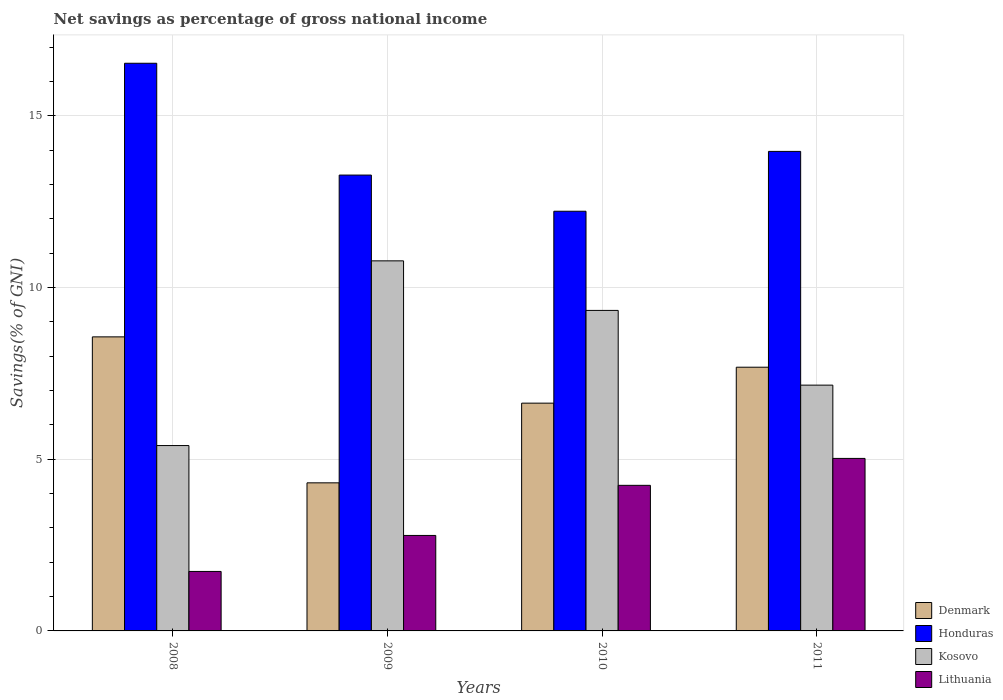How many groups of bars are there?
Keep it short and to the point. 4. Are the number of bars per tick equal to the number of legend labels?
Ensure brevity in your answer.  Yes. Are the number of bars on each tick of the X-axis equal?
Your answer should be compact. Yes. How many bars are there on the 3rd tick from the left?
Provide a succinct answer. 4. What is the label of the 1st group of bars from the left?
Offer a terse response. 2008. In how many cases, is the number of bars for a given year not equal to the number of legend labels?
Your answer should be compact. 0. What is the total savings in Lithuania in 2009?
Your answer should be very brief. 2.78. Across all years, what is the maximum total savings in Honduras?
Your answer should be very brief. 16.53. Across all years, what is the minimum total savings in Honduras?
Ensure brevity in your answer.  12.22. What is the total total savings in Lithuania in the graph?
Offer a terse response. 13.77. What is the difference between the total savings in Honduras in 2008 and that in 2009?
Provide a short and direct response. 3.26. What is the difference between the total savings in Kosovo in 2008 and the total savings in Denmark in 2010?
Your answer should be very brief. -1.23. What is the average total savings in Denmark per year?
Offer a terse response. 6.8. In the year 2009, what is the difference between the total savings in Honduras and total savings in Kosovo?
Provide a succinct answer. 2.5. What is the ratio of the total savings in Denmark in 2008 to that in 2009?
Provide a succinct answer. 1.99. Is the difference between the total savings in Honduras in 2008 and 2009 greater than the difference between the total savings in Kosovo in 2008 and 2009?
Your response must be concise. Yes. What is the difference between the highest and the second highest total savings in Kosovo?
Your answer should be very brief. 1.44. What is the difference between the highest and the lowest total savings in Kosovo?
Make the answer very short. 5.38. In how many years, is the total savings in Lithuania greater than the average total savings in Lithuania taken over all years?
Provide a succinct answer. 2. What does the 3rd bar from the left in 2008 represents?
Ensure brevity in your answer.  Kosovo. What does the 4th bar from the right in 2011 represents?
Your response must be concise. Denmark. Is it the case that in every year, the sum of the total savings in Honduras and total savings in Lithuania is greater than the total savings in Kosovo?
Offer a terse response. Yes. What is the difference between two consecutive major ticks on the Y-axis?
Offer a very short reply. 5. Are the values on the major ticks of Y-axis written in scientific E-notation?
Provide a succinct answer. No. Where does the legend appear in the graph?
Give a very brief answer. Bottom right. What is the title of the graph?
Keep it short and to the point. Net savings as percentage of gross national income. What is the label or title of the Y-axis?
Keep it short and to the point. Savings(% of GNI). What is the Savings(% of GNI) in Denmark in 2008?
Provide a succinct answer. 8.56. What is the Savings(% of GNI) in Honduras in 2008?
Provide a short and direct response. 16.53. What is the Savings(% of GNI) in Kosovo in 2008?
Offer a very short reply. 5.4. What is the Savings(% of GNI) in Lithuania in 2008?
Provide a short and direct response. 1.73. What is the Savings(% of GNI) of Denmark in 2009?
Give a very brief answer. 4.31. What is the Savings(% of GNI) in Honduras in 2009?
Ensure brevity in your answer.  13.27. What is the Savings(% of GNI) of Kosovo in 2009?
Offer a terse response. 10.77. What is the Savings(% of GNI) in Lithuania in 2009?
Ensure brevity in your answer.  2.78. What is the Savings(% of GNI) in Denmark in 2010?
Offer a very short reply. 6.63. What is the Savings(% of GNI) of Honduras in 2010?
Your response must be concise. 12.22. What is the Savings(% of GNI) in Kosovo in 2010?
Provide a succinct answer. 9.33. What is the Savings(% of GNI) in Lithuania in 2010?
Offer a terse response. 4.24. What is the Savings(% of GNI) of Denmark in 2011?
Give a very brief answer. 7.68. What is the Savings(% of GNI) in Honduras in 2011?
Offer a very short reply. 13.96. What is the Savings(% of GNI) in Kosovo in 2011?
Your response must be concise. 7.16. What is the Savings(% of GNI) of Lithuania in 2011?
Provide a short and direct response. 5.02. Across all years, what is the maximum Savings(% of GNI) of Denmark?
Provide a succinct answer. 8.56. Across all years, what is the maximum Savings(% of GNI) of Honduras?
Your answer should be very brief. 16.53. Across all years, what is the maximum Savings(% of GNI) in Kosovo?
Offer a very short reply. 10.77. Across all years, what is the maximum Savings(% of GNI) of Lithuania?
Keep it short and to the point. 5.02. Across all years, what is the minimum Savings(% of GNI) of Denmark?
Ensure brevity in your answer.  4.31. Across all years, what is the minimum Savings(% of GNI) in Honduras?
Keep it short and to the point. 12.22. Across all years, what is the minimum Savings(% of GNI) in Kosovo?
Give a very brief answer. 5.4. Across all years, what is the minimum Savings(% of GNI) in Lithuania?
Your answer should be very brief. 1.73. What is the total Savings(% of GNI) of Denmark in the graph?
Provide a succinct answer. 27.18. What is the total Savings(% of GNI) of Honduras in the graph?
Keep it short and to the point. 55.98. What is the total Savings(% of GNI) of Kosovo in the graph?
Provide a succinct answer. 32.66. What is the total Savings(% of GNI) of Lithuania in the graph?
Keep it short and to the point. 13.77. What is the difference between the Savings(% of GNI) of Denmark in 2008 and that in 2009?
Your answer should be very brief. 4.25. What is the difference between the Savings(% of GNI) of Honduras in 2008 and that in 2009?
Give a very brief answer. 3.26. What is the difference between the Savings(% of GNI) of Kosovo in 2008 and that in 2009?
Ensure brevity in your answer.  -5.38. What is the difference between the Savings(% of GNI) of Lithuania in 2008 and that in 2009?
Your answer should be very brief. -1.05. What is the difference between the Savings(% of GNI) in Denmark in 2008 and that in 2010?
Provide a short and direct response. 1.93. What is the difference between the Savings(% of GNI) of Honduras in 2008 and that in 2010?
Make the answer very short. 4.31. What is the difference between the Savings(% of GNI) in Kosovo in 2008 and that in 2010?
Your response must be concise. -3.93. What is the difference between the Savings(% of GNI) in Lithuania in 2008 and that in 2010?
Offer a terse response. -2.51. What is the difference between the Savings(% of GNI) in Denmark in 2008 and that in 2011?
Provide a succinct answer. 0.88. What is the difference between the Savings(% of GNI) of Honduras in 2008 and that in 2011?
Make the answer very short. 2.57. What is the difference between the Savings(% of GNI) in Kosovo in 2008 and that in 2011?
Make the answer very short. -1.76. What is the difference between the Savings(% of GNI) in Lithuania in 2008 and that in 2011?
Your answer should be very brief. -3.29. What is the difference between the Savings(% of GNI) of Denmark in 2009 and that in 2010?
Your answer should be compact. -2.32. What is the difference between the Savings(% of GNI) of Honduras in 2009 and that in 2010?
Your answer should be very brief. 1.05. What is the difference between the Savings(% of GNI) in Kosovo in 2009 and that in 2010?
Offer a terse response. 1.44. What is the difference between the Savings(% of GNI) of Lithuania in 2009 and that in 2010?
Your answer should be compact. -1.46. What is the difference between the Savings(% of GNI) of Denmark in 2009 and that in 2011?
Offer a very short reply. -3.37. What is the difference between the Savings(% of GNI) of Honduras in 2009 and that in 2011?
Ensure brevity in your answer.  -0.69. What is the difference between the Savings(% of GNI) of Kosovo in 2009 and that in 2011?
Your response must be concise. 3.62. What is the difference between the Savings(% of GNI) in Lithuania in 2009 and that in 2011?
Offer a very short reply. -2.24. What is the difference between the Savings(% of GNI) in Denmark in 2010 and that in 2011?
Provide a short and direct response. -1.05. What is the difference between the Savings(% of GNI) in Honduras in 2010 and that in 2011?
Provide a short and direct response. -1.74. What is the difference between the Savings(% of GNI) in Kosovo in 2010 and that in 2011?
Provide a short and direct response. 2.18. What is the difference between the Savings(% of GNI) in Lithuania in 2010 and that in 2011?
Your response must be concise. -0.78. What is the difference between the Savings(% of GNI) in Denmark in 2008 and the Savings(% of GNI) in Honduras in 2009?
Make the answer very short. -4.71. What is the difference between the Savings(% of GNI) of Denmark in 2008 and the Savings(% of GNI) of Kosovo in 2009?
Offer a terse response. -2.21. What is the difference between the Savings(% of GNI) in Denmark in 2008 and the Savings(% of GNI) in Lithuania in 2009?
Give a very brief answer. 5.78. What is the difference between the Savings(% of GNI) in Honduras in 2008 and the Savings(% of GNI) in Kosovo in 2009?
Your answer should be compact. 5.75. What is the difference between the Savings(% of GNI) in Honduras in 2008 and the Savings(% of GNI) in Lithuania in 2009?
Your answer should be compact. 13.75. What is the difference between the Savings(% of GNI) of Kosovo in 2008 and the Savings(% of GNI) of Lithuania in 2009?
Keep it short and to the point. 2.62. What is the difference between the Savings(% of GNI) in Denmark in 2008 and the Savings(% of GNI) in Honduras in 2010?
Your answer should be compact. -3.66. What is the difference between the Savings(% of GNI) in Denmark in 2008 and the Savings(% of GNI) in Kosovo in 2010?
Provide a short and direct response. -0.77. What is the difference between the Savings(% of GNI) of Denmark in 2008 and the Savings(% of GNI) of Lithuania in 2010?
Your answer should be compact. 4.32. What is the difference between the Savings(% of GNI) of Honduras in 2008 and the Savings(% of GNI) of Kosovo in 2010?
Keep it short and to the point. 7.2. What is the difference between the Savings(% of GNI) of Honduras in 2008 and the Savings(% of GNI) of Lithuania in 2010?
Offer a very short reply. 12.29. What is the difference between the Savings(% of GNI) of Kosovo in 2008 and the Savings(% of GNI) of Lithuania in 2010?
Offer a very short reply. 1.16. What is the difference between the Savings(% of GNI) in Denmark in 2008 and the Savings(% of GNI) in Honduras in 2011?
Make the answer very short. -5.4. What is the difference between the Savings(% of GNI) of Denmark in 2008 and the Savings(% of GNI) of Kosovo in 2011?
Offer a very short reply. 1.41. What is the difference between the Savings(% of GNI) in Denmark in 2008 and the Savings(% of GNI) in Lithuania in 2011?
Ensure brevity in your answer.  3.54. What is the difference between the Savings(% of GNI) of Honduras in 2008 and the Savings(% of GNI) of Kosovo in 2011?
Ensure brevity in your answer.  9.37. What is the difference between the Savings(% of GNI) in Honduras in 2008 and the Savings(% of GNI) in Lithuania in 2011?
Offer a terse response. 11.51. What is the difference between the Savings(% of GNI) in Kosovo in 2008 and the Savings(% of GNI) in Lithuania in 2011?
Your response must be concise. 0.37. What is the difference between the Savings(% of GNI) in Denmark in 2009 and the Savings(% of GNI) in Honduras in 2010?
Your answer should be compact. -7.91. What is the difference between the Savings(% of GNI) of Denmark in 2009 and the Savings(% of GNI) of Kosovo in 2010?
Offer a very short reply. -5.02. What is the difference between the Savings(% of GNI) in Denmark in 2009 and the Savings(% of GNI) in Lithuania in 2010?
Offer a very short reply. 0.07. What is the difference between the Savings(% of GNI) of Honduras in 2009 and the Savings(% of GNI) of Kosovo in 2010?
Provide a succinct answer. 3.94. What is the difference between the Savings(% of GNI) in Honduras in 2009 and the Savings(% of GNI) in Lithuania in 2010?
Your answer should be very brief. 9.03. What is the difference between the Savings(% of GNI) in Kosovo in 2009 and the Savings(% of GNI) in Lithuania in 2010?
Offer a very short reply. 6.54. What is the difference between the Savings(% of GNI) in Denmark in 2009 and the Savings(% of GNI) in Honduras in 2011?
Offer a terse response. -9.65. What is the difference between the Savings(% of GNI) of Denmark in 2009 and the Savings(% of GNI) of Kosovo in 2011?
Ensure brevity in your answer.  -2.85. What is the difference between the Savings(% of GNI) in Denmark in 2009 and the Savings(% of GNI) in Lithuania in 2011?
Your answer should be very brief. -0.71. What is the difference between the Savings(% of GNI) of Honduras in 2009 and the Savings(% of GNI) of Kosovo in 2011?
Your answer should be compact. 6.12. What is the difference between the Savings(% of GNI) in Honduras in 2009 and the Savings(% of GNI) in Lithuania in 2011?
Offer a terse response. 8.25. What is the difference between the Savings(% of GNI) of Kosovo in 2009 and the Savings(% of GNI) of Lithuania in 2011?
Provide a succinct answer. 5.75. What is the difference between the Savings(% of GNI) of Denmark in 2010 and the Savings(% of GNI) of Honduras in 2011?
Your answer should be very brief. -7.33. What is the difference between the Savings(% of GNI) in Denmark in 2010 and the Savings(% of GNI) in Kosovo in 2011?
Your response must be concise. -0.52. What is the difference between the Savings(% of GNI) in Denmark in 2010 and the Savings(% of GNI) in Lithuania in 2011?
Provide a succinct answer. 1.61. What is the difference between the Savings(% of GNI) in Honduras in 2010 and the Savings(% of GNI) in Kosovo in 2011?
Your answer should be compact. 5.06. What is the difference between the Savings(% of GNI) in Honduras in 2010 and the Savings(% of GNI) in Lithuania in 2011?
Provide a short and direct response. 7.2. What is the difference between the Savings(% of GNI) in Kosovo in 2010 and the Savings(% of GNI) in Lithuania in 2011?
Keep it short and to the point. 4.31. What is the average Savings(% of GNI) in Denmark per year?
Your answer should be compact. 6.8. What is the average Savings(% of GNI) in Honduras per year?
Your answer should be compact. 14. What is the average Savings(% of GNI) of Kosovo per year?
Make the answer very short. 8.17. What is the average Savings(% of GNI) in Lithuania per year?
Your answer should be compact. 3.44. In the year 2008, what is the difference between the Savings(% of GNI) in Denmark and Savings(% of GNI) in Honduras?
Your answer should be compact. -7.97. In the year 2008, what is the difference between the Savings(% of GNI) in Denmark and Savings(% of GNI) in Kosovo?
Provide a succinct answer. 3.16. In the year 2008, what is the difference between the Savings(% of GNI) in Denmark and Savings(% of GNI) in Lithuania?
Provide a succinct answer. 6.83. In the year 2008, what is the difference between the Savings(% of GNI) of Honduras and Savings(% of GNI) of Kosovo?
Give a very brief answer. 11.13. In the year 2008, what is the difference between the Savings(% of GNI) of Honduras and Savings(% of GNI) of Lithuania?
Your response must be concise. 14.8. In the year 2008, what is the difference between the Savings(% of GNI) of Kosovo and Savings(% of GNI) of Lithuania?
Give a very brief answer. 3.67. In the year 2009, what is the difference between the Savings(% of GNI) in Denmark and Savings(% of GNI) in Honduras?
Provide a succinct answer. -8.96. In the year 2009, what is the difference between the Savings(% of GNI) of Denmark and Savings(% of GNI) of Kosovo?
Make the answer very short. -6.46. In the year 2009, what is the difference between the Savings(% of GNI) in Denmark and Savings(% of GNI) in Lithuania?
Make the answer very short. 1.53. In the year 2009, what is the difference between the Savings(% of GNI) in Honduras and Savings(% of GNI) in Kosovo?
Ensure brevity in your answer.  2.5. In the year 2009, what is the difference between the Savings(% of GNI) of Honduras and Savings(% of GNI) of Lithuania?
Give a very brief answer. 10.49. In the year 2009, what is the difference between the Savings(% of GNI) in Kosovo and Savings(% of GNI) in Lithuania?
Offer a terse response. 8. In the year 2010, what is the difference between the Savings(% of GNI) of Denmark and Savings(% of GNI) of Honduras?
Offer a very short reply. -5.59. In the year 2010, what is the difference between the Savings(% of GNI) in Denmark and Savings(% of GNI) in Kosovo?
Give a very brief answer. -2.7. In the year 2010, what is the difference between the Savings(% of GNI) of Denmark and Savings(% of GNI) of Lithuania?
Offer a very short reply. 2.39. In the year 2010, what is the difference between the Savings(% of GNI) of Honduras and Savings(% of GNI) of Kosovo?
Your answer should be very brief. 2.89. In the year 2010, what is the difference between the Savings(% of GNI) of Honduras and Savings(% of GNI) of Lithuania?
Ensure brevity in your answer.  7.98. In the year 2010, what is the difference between the Savings(% of GNI) of Kosovo and Savings(% of GNI) of Lithuania?
Your response must be concise. 5.09. In the year 2011, what is the difference between the Savings(% of GNI) of Denmark and Savings(% of GNI) of Honduras?
Give a very brief answer. -6.28. In the year 2011, what is the difference between the Savings(% of GNI) in Denmark and Savings(% of GNI) in Kosovo?
Keep it short and to the point. 0.52. In the year 2011, what is the difference between the Savings(% of GNI) of Denmark and Savings(% of GNI) of Lithuania?
Offer a terse response. 2.66. In the year 2011, what is the difference between the Savings(% of GNI) in Honduras and Savings(% of GNI) in Kosovo?
Your response must be concise. 6.81. In the year 2011, what is the difference between the Savings(% of GNI) of Honduras and Savings(% of GNI) of Lithuania?
Make the answer very short. 8.94. In the year 2011, what is the difference between the Savings(% of GNI) in Kosovo and Savings(% of GNI) in Lithuania?
Provide a short and direct response. 2.13. What is the ratio of the Savings(% of GNI) in Denmark in 2008 to that in 2009?
Keep it short and to the point. 1.99. What is the ratio of the Savings(% of GNI) in Honduras in 2008 to that in 2009?
Provide a succinct answer. 1.25. What is the ratio of the Savings(% of GNI) of Kosovo in 2008 to that in 2009?
Your answer should be very brief. 0.5. What is the ratio of the Savings(% of GNI) of Lithuania in 2008 to that in 2009?
Ensure brevity in your answer.  0.62. What is the ratio of the Savings(% of GNI) in Denmark in 2008 to that in 2010?
Your answer should be compact. 1.29. What is the ratio of the Savings(% of GNI) in Honduras in 2008 to that in 2010?
Give a very brief answer. 1.35. What is the ratio of the Savings(% of GNI) of Kosovo in 2008 to that in 2010?
Provide a succinct answer. 0.58. What is the ratio of the Savings(% of GNI) of Lithuania in 2008 to that in 2010?
Your response must be concise. 0.41. What is the ratio of the Savings(% of GNI) of Denmark in 2008 to that in 2011?
Provide a short and direct response. 1.12. What is the ratio of the Savings(% of GNI) of Honduras in 2008 to that in 2011?
Keep it short and to the point. 1.18. What is the ratio of the Savings(% of GNI) in Kosovo in 2008 to that in 2011?
Keep it short and to the point. 0.75. What is the ratio of the Savings(% of GNI) of Lithuania in 2008 to that in 2011?
Your answer should be very brief. 0.34. What is the ratio of the Savings(% of GNI) in Denmark in 2009 to that in 2010?
Offer a very short reply. 0.65. What is the ratio of the Savings(% of GNI) of Honduras in 2009 to that in 2010?
Provide a short and direct response. 1.09. What is the ratio of the Savings(% of GNI) in Kosovo in 2009 to that in 2010?
Your response must be concise. 1.15. What is the ratio of the Savings(% of GNI) in Lithuania in 2009 to that in 2010?
Keep it short and to the point. 0.66. What is the ratio of the Savings(% of GNI) in Denmark in 2009 to that in 2011?
Ensure brevity in your answer.  0.56. What is the ratio of the Savings(% of GNI) in Honduras in 2009 to that in 2011?
Your answer should be very brief. 0.95. What is the ratio of the Savings(% of GNI) in Kosovo in 2009 to that in 2011?
Make the answer very short. 1.51. What is the ratio of the Savings(% of GNI) in Lithuania in 2009 to that in 2011?
Offer a terse response. 0.55. What is the ratio of the Savings(% of GNI) in Denmark in 2010 to that in 2011?
Keep it short and to the point. 0.86. What is the ratio of the Savings(% of GNI) of Honduras in 2010 to that in 2011?
Ensure brevity in your answer.  0.88. What is the ratio of the Savings(% of GNI) of Kosovo in 2010 to that in 2011?
Make the answer very short. 1.3. What is the ratio of the Savings(% of GNI) in Lithuania in 2010 to that in 2011?
Your answer should be compact. 0.84. What is the difference between the highest and the second highest Savings(% of GNI) of Denmark?
Your answer should be compact. 0.88. What is the difference between the highest and the second highest Savings(% of GNI) in Honduras?
Keep it short and to the point. 2.57. What is the difference between the highest and the second highest Savings(% of GNI) in Kosovo?
Offer a terse response. 1.44. What is the difference between the highest and the second highest Savings(% of GNI) of Lithuania?
Provide a succinct answer. 0.78. What is the difference between the highest and the lowest Savings(% of GNI) of Denmark?
Keep it short and to the point. 4.25. What is the difference between the highest and the lowest Savings(% of GNI) in Honduras?
Offer a very short reply. 4.31. What is the difference between the highest and the lowest Savings(% of GNI) of Kosovo?
Provide a succinct answer. 5.38. What is the difference between the highest and the lowest Savings(% of GNI) of Lithuania?
Ensure brevity in your answer.  3.29. 